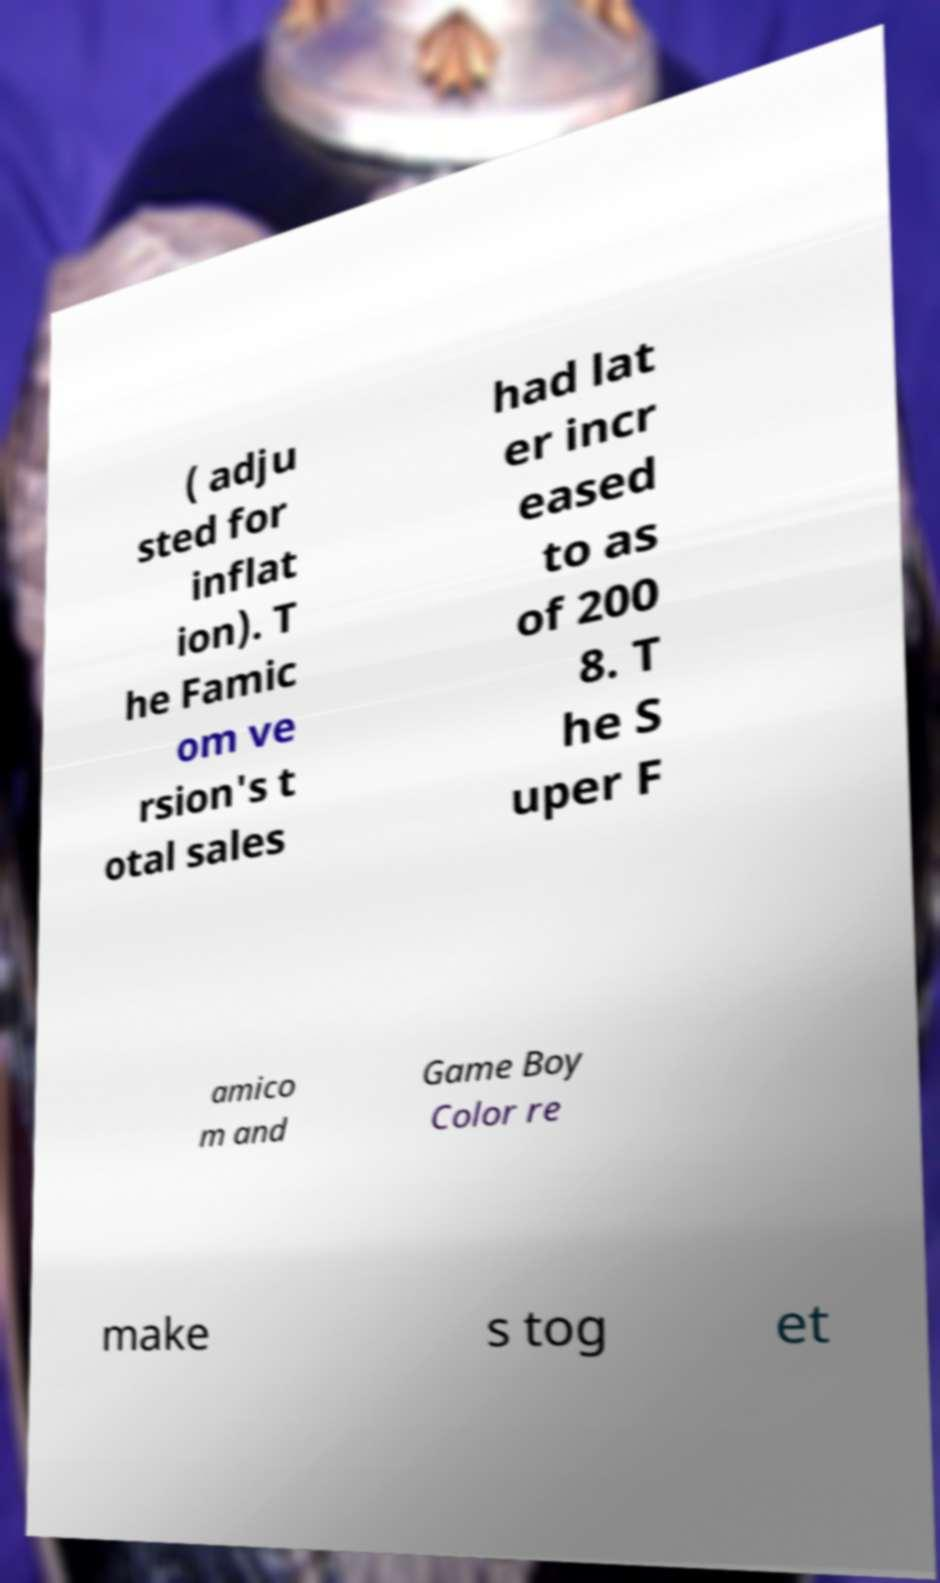There's text embedded in this image that I need extracted. Can you transcribe it verbatim? ( adju sted for inflat ion). T he Famic om ve rsion's t otal sales had lat er incr eased to as of 200 8. T he S uper F amico m and Game Boy Color re make s tog et 